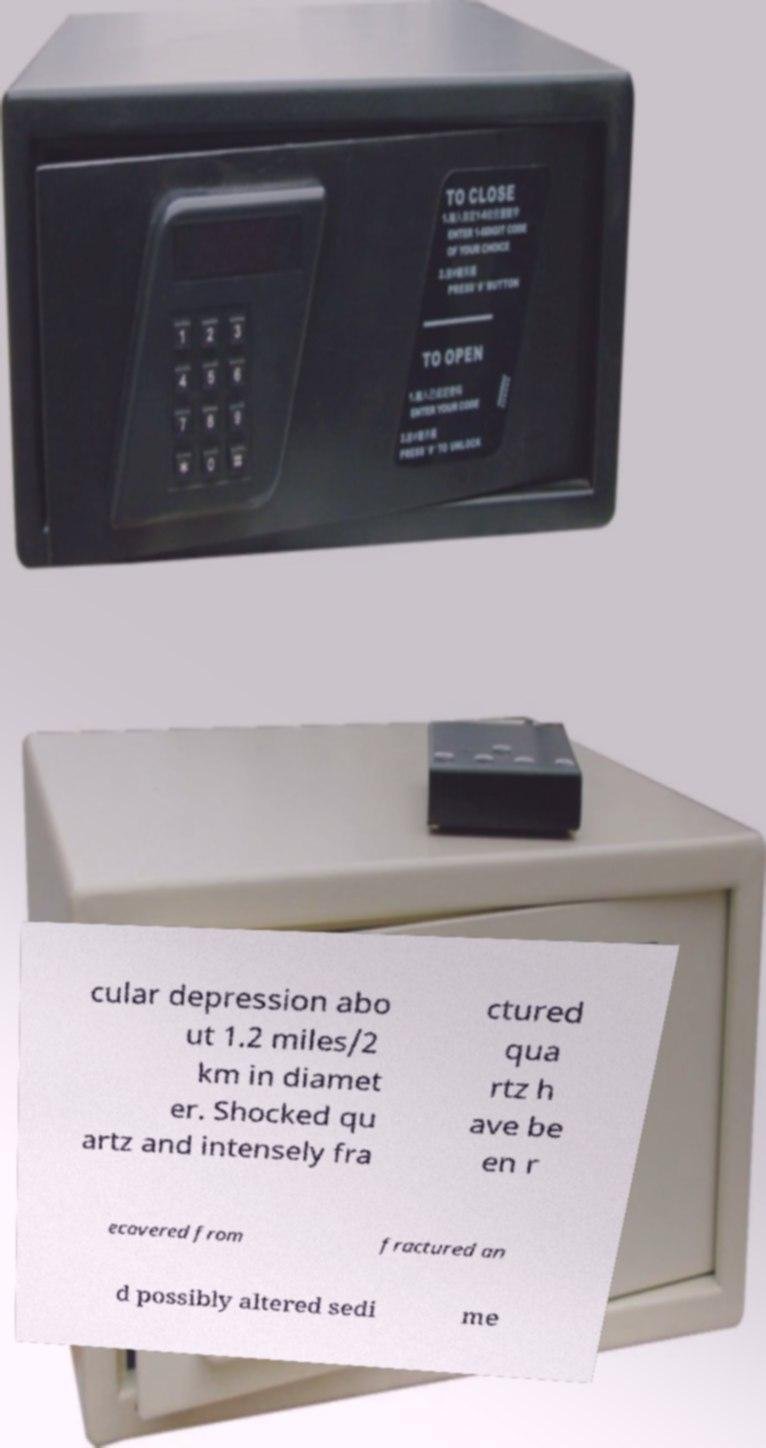There's text embedded in this image that I need extracted. Can you transcribe it verbatim? cular depression abo ut 1.2 miles/2 km in diamet er. Shocked qu artz and intensely fra ctured qua rtz h ave be en r ecovered from fractured an d possibly altered sedi me 